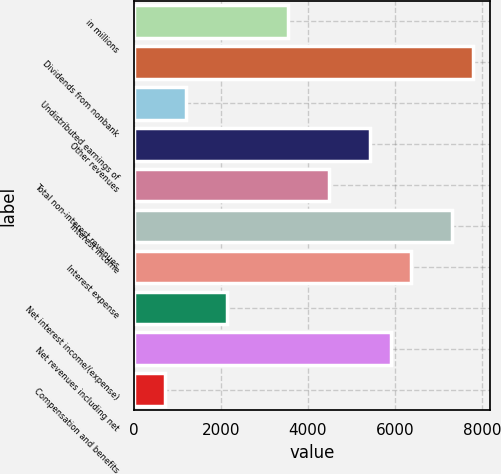Convert chart. <chart><loc_0><loc_0><loc_500><loc_500><bar_chart><fcel>in millions<fcel>Dividends from nonbank<fcel>Undistributed earnings of<fcel>Other revenues<fcel>Total non-interest revenues<fcel>Interest income<fcel>Interest expense<fcel>Net interest income/(expense)<fcel>Net revenues including net<fcel>Compensation and benefits<nl><fcel>3552.5<fcel>7796<fcel>1195<fcel>5438.5<fcel>4495.5<fcel>7324.5<fcel>6381.5<fcel>2138<fcel>5910<fcel>723.5<nl></chart> 